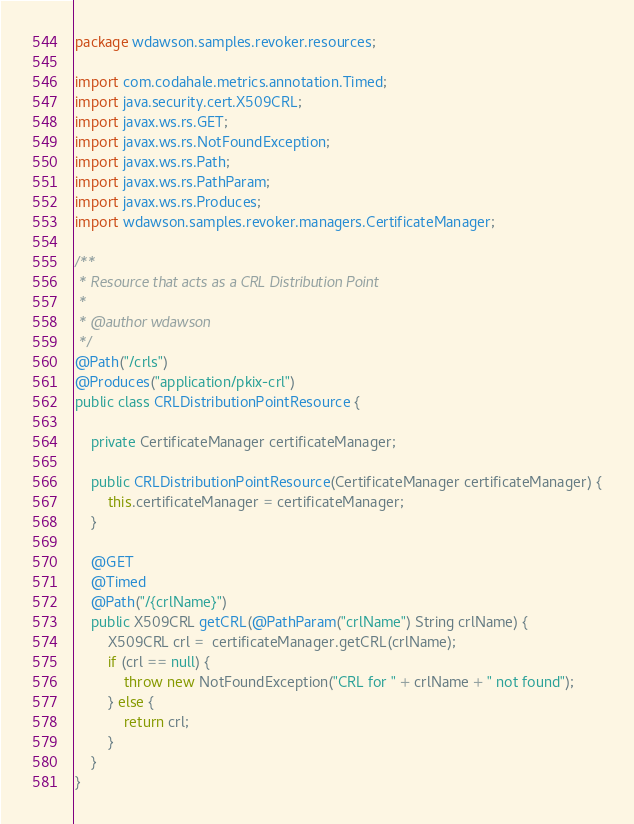<code> <loc_0><loc_0><loc_500><loc_500><_Java_>package wdawson.samples.revoker.resources;

import com.codahale.metrics.annotation.Timed;
import java.security.cert.X509CRL;
import javax.ws.rs.GET;
import javax.ws.rs.NotFoundException;
import javax.ws.rs.Path;
import javax.ws.rs.PathParam;
import javax.ws.rs.Produces;
import wdawson.samples.revoker.managers.CertificateManager;

/**
 * Resource that acts as a CRL Distribution Point
 *
 * @author wdawson
 */
@Path("/crls")
@Produces("application/pkix-crl")
public class CRLDistributionPointResource {

    private CertificateManager certificateManager;

    public CRLDistributionPointResource(CertificateManager certificateManager) {
        this.certificateManager = certificateManager;
    }

    @GET
    @Timed
    @Path("/{crlName}")
    public X509CRL getCRL(@PathParam("crlName") String crlName) {
        X509CRL crl =  certificateManager.getCRL(crlName);
        if (crl == null) {
            throw new NotFoundException("CRL for " + crlName + " not found");
        } else {
            return crl;
        }
    }
}
</code> 